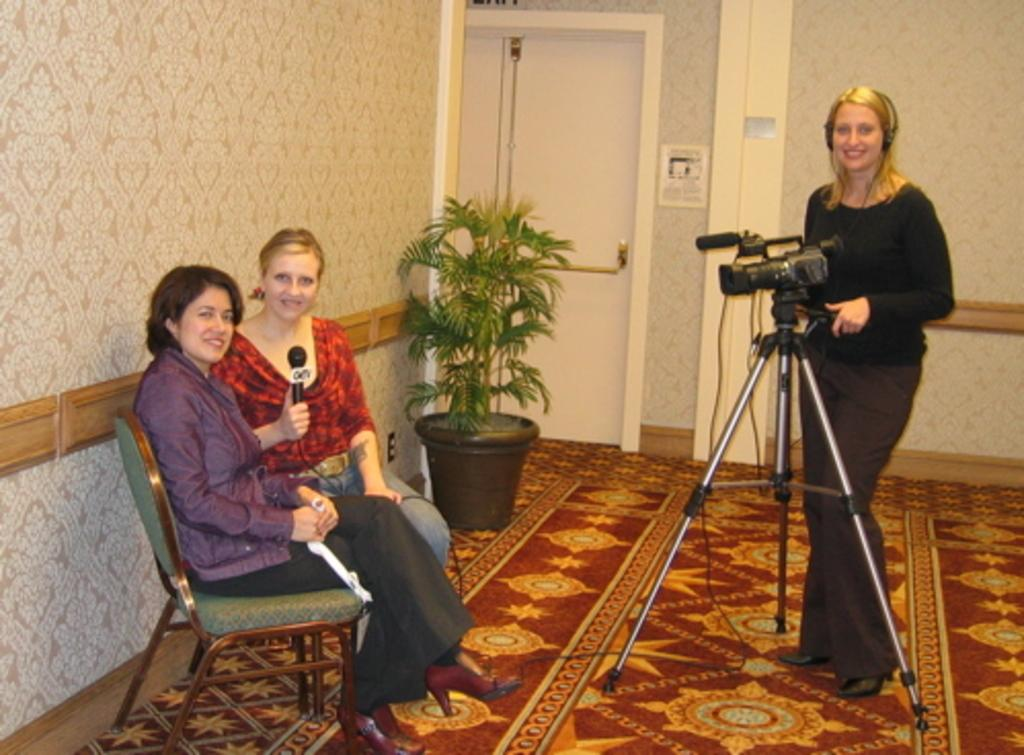How many women are sitting on the chair in the image? There are two women sitting on a chair in the image. What can be seen in the image besides the women sitting on the chair? There is a mic, a woman standing, a camera, a flower pot, a door, and a carpet in the image. What type of ray is visible in the image? There is no ray present in the image. How many pins are holding the door in the image? There is no pin present in the image, and the door is not being held by any pins. 